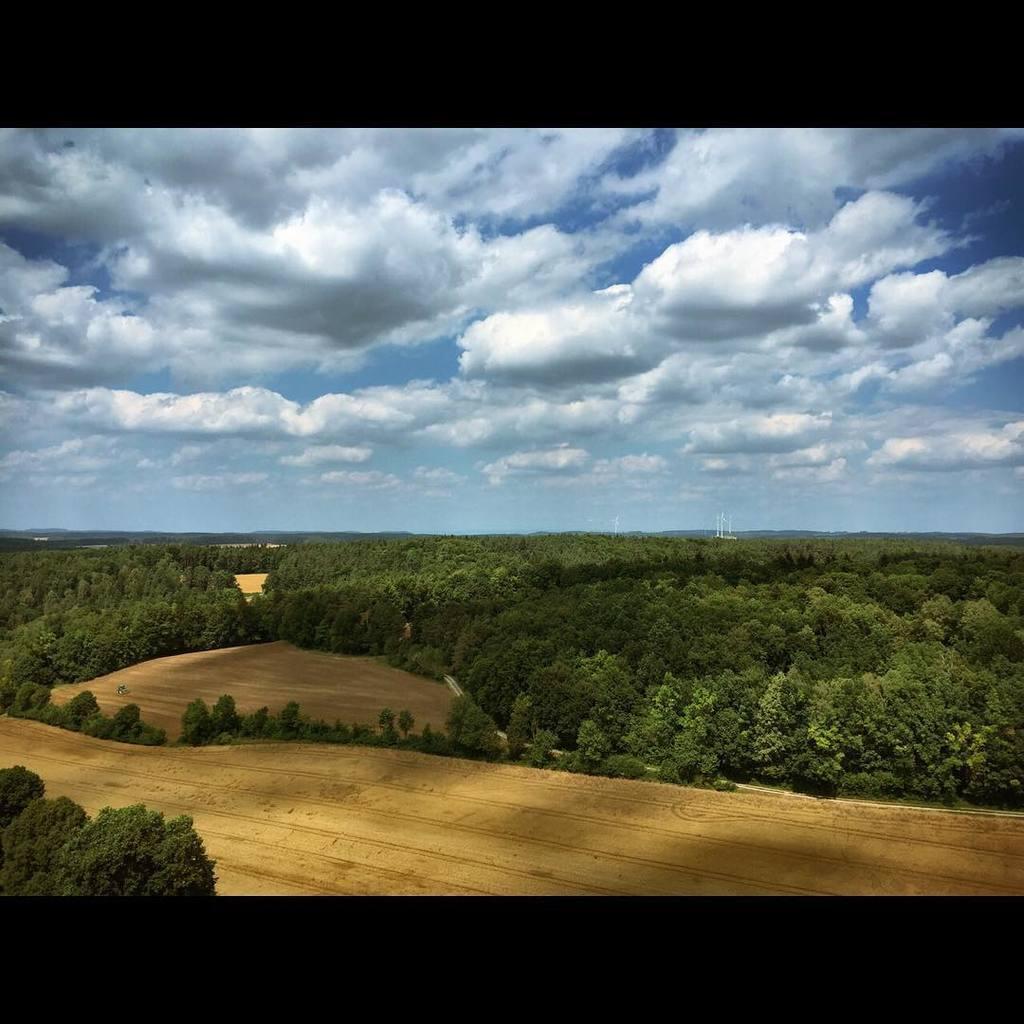Describe this image in one or two sentences. In this image we can see a group of trees on the ground. On the backside we can see some poles and the sky which looks cloudy. 